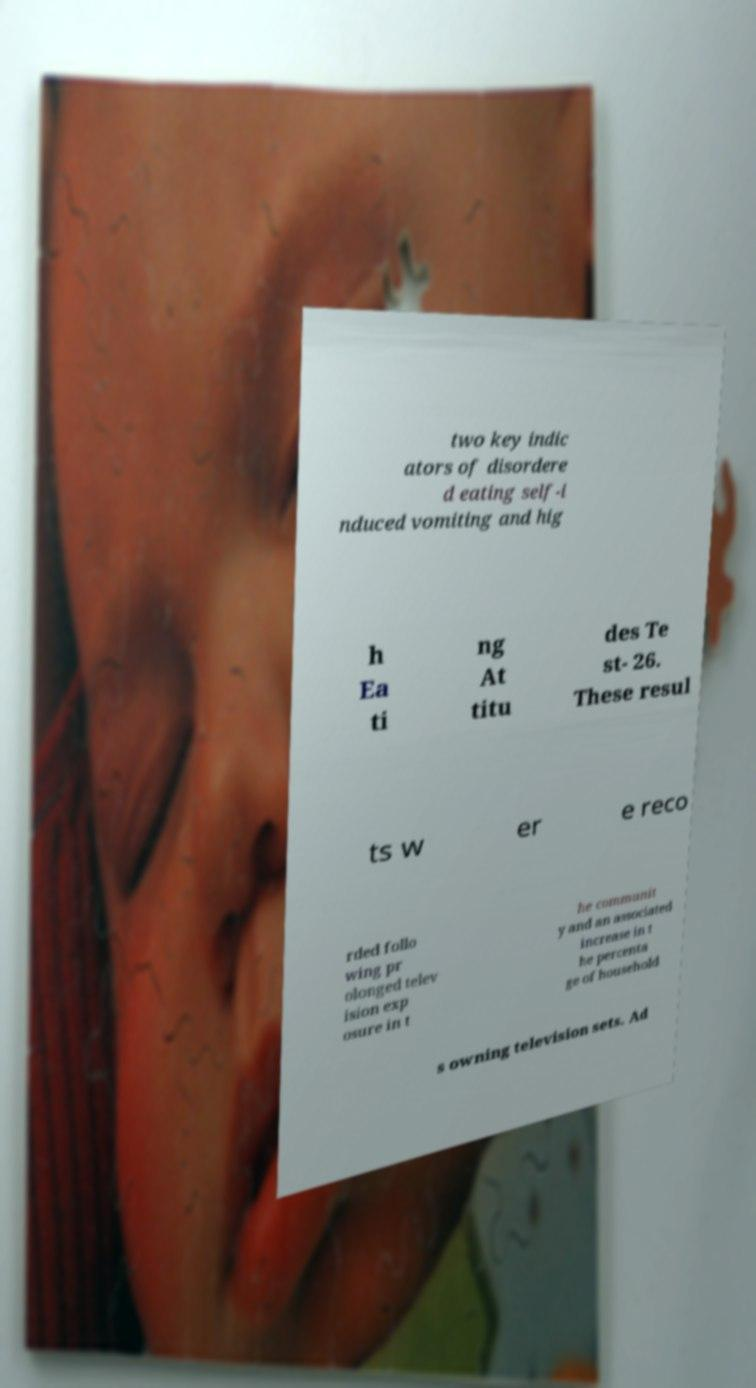Can you read and provide the text displayed in the image?This photo seems to have some interesting text. Can you extract and type it out for me? two key indic ators of disordere d eating self-i nduced vomiting and hig h Ea ti ng At titu des Te st- 26. These resul ts w er e reco rded follo wing pr olonged telev ision exp osure in t he communit y and an associated increase in t he percenta ge of household s owning television sets. Ad 